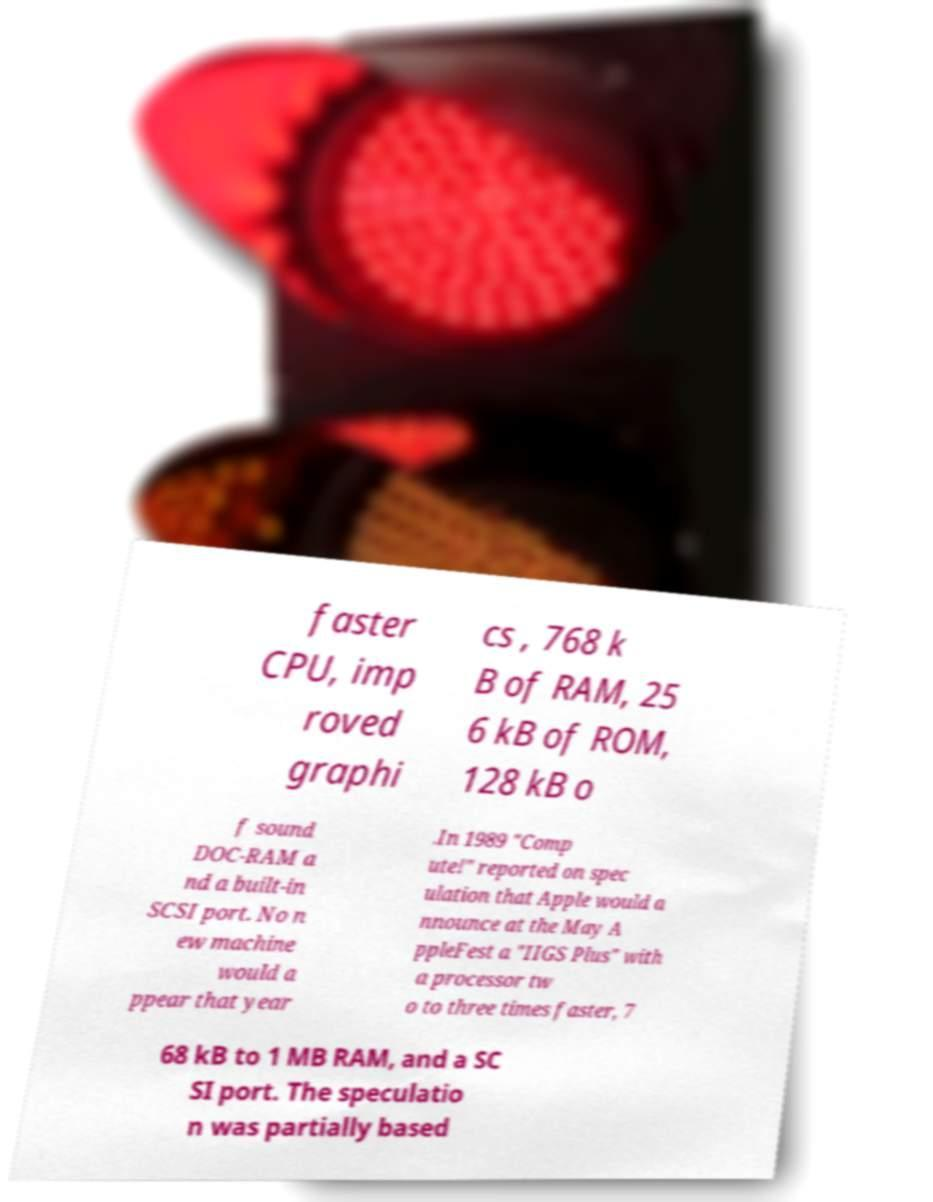What messages or text are displayed in this image? I need them in a readable, typed format. faster CPU, imp roved graphi cs , 768 k B of RAM, 25 6 kB of ROM, 128 kB o f sound DOC-RAM a nd a built-in SCSI port. No n ew machine would a ppear that year .In 1989 "Comp ute!" reported on spec ulation that Apple would a nnounce at the May A ppleFest a "IIGS Plus" with a processor tw o to three times faster, 7 68 kB to 1 MB RAM, and a SC SI port. The speculatio n was partially based 